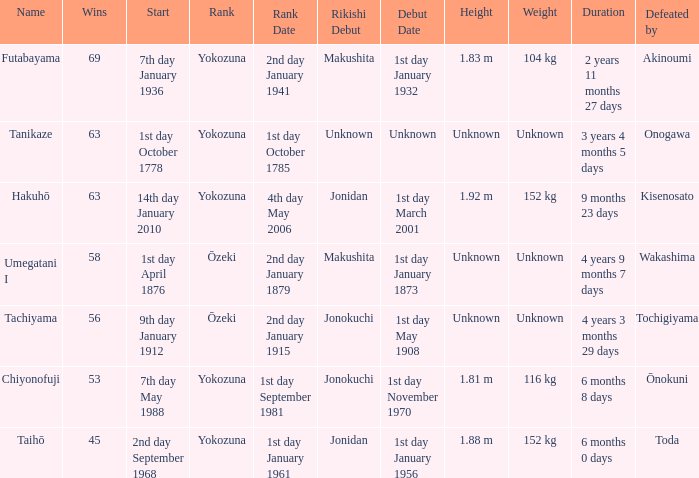How many wins were held before being defeated by toda? 1.0. 